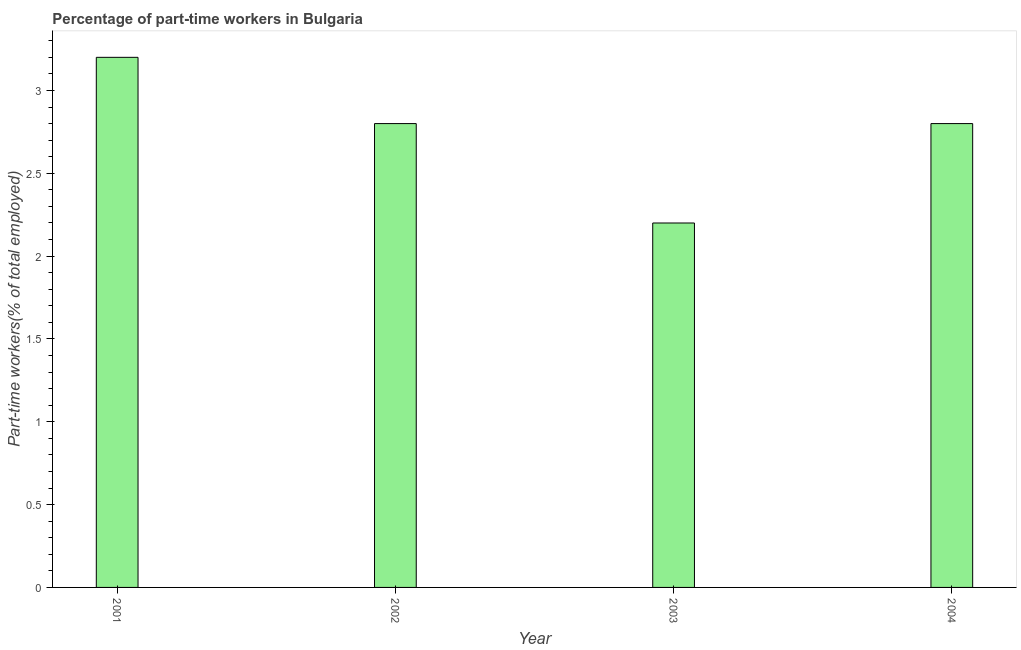Does the graph contain grids?
Provide a succinct answer. No. What is the title of the graph?
Your answer should be compact. Percentage of part-time workers in Bulgaria. What is the label or title of the Y-axis?
Make the answer very short. Part-time workers(% of total employed). What is the percentage of part-time workers in 2001?
Offer a terse response. 3.2. Across all years, what is the maximum percentage of part-time workers?
Make the answer very short. 3.2. Across all years, what is the minimum percentage of part-time workers?
Offer a terse response. 2.2. In which year was the percentage of part-time workers maximum?
Make the answer very short. 2001. In which year was the percentage of part-time workers minimum?
Your response must be concise. 2003. What is the difference between the percentage of part-time workers in 2001 and 2003?
Give a very brief answer. 1. What is the average percentage of part-time workers per year?
Give a very brief answer. 2.75. What is the median percentage of part-time workers?
Ensure brevity in your answer.  2.8. In how many years, is the percentage of part-time workers greater than 1.5 %?
Give a very brief answer. 4. Do a majority of the years between 2003 and 2001 (inclusive) have percentage of part-time workers greater than 2 %?
Offer a very short reply. Yes. What is the ratio of the percentage of part-time workers in 2001 to that in 2003?
Offer a terse response. 1.46. Is the percentage of part-time workers in 2003 less than that in 2004?
Your response must be concise. Yes. What is the difference between the highest and the second highest percentage of part-time workers?
Your answer should be very brief. 0.4. In how many years, is the percentage of part-time workers greater than the average percentage of part-time workers taken over all years?
Offer a very short reply. 3. How many bars are there?
Provide a succinct answer. 4. How many years are there in the graph?
Offer a very short reply. 4. Are the values on the major ticks of Y-axis written in scientific E-notation?
Your answer should be very brief. No. What is the Part-time workers(% of total employed) of 2001?
Your response must be concise. 3.2. What is the Part-time workers(% of total employed) in 2002?
Offer a terse response. 2.8. What is the Part-time workers(% of total employed) in 2003?
Make the answer very short. 2.2. What is the Part-time workers(% of total employed) of 2004?
Provide a short and direct response. 2.8. What is the difference between the Part-time workers(% of total employed) in 2002 and 2003?
Offer a terse response. 0.6. What is the difference between the Part-time workers(% of total employed) in 2003 and 2004?
Offer a very short reply. -0.6. What is the ratio of the Part-time workers(% of total employed) in 2001 to that in 2002?
Ensure brevity in your answer.  1.14. What is the ratio of the Part-time workers(% of total employed) in 2001 to that in 2003?
Offer a terse response. 1.46. What is the ratio of the Part-time workers(% of total employed) in 2001 to that in 2004?
Provide a succinct answer. 1.14. What is the ratio of the Part-time workers(% of total employed) in 2002 to that in 2003?
Your answer should be compact. 1.27. What is the ratio of the Part-time workers(% of total employed) in 2003 to that in 2004?
Your response must be concise. 0.79. 